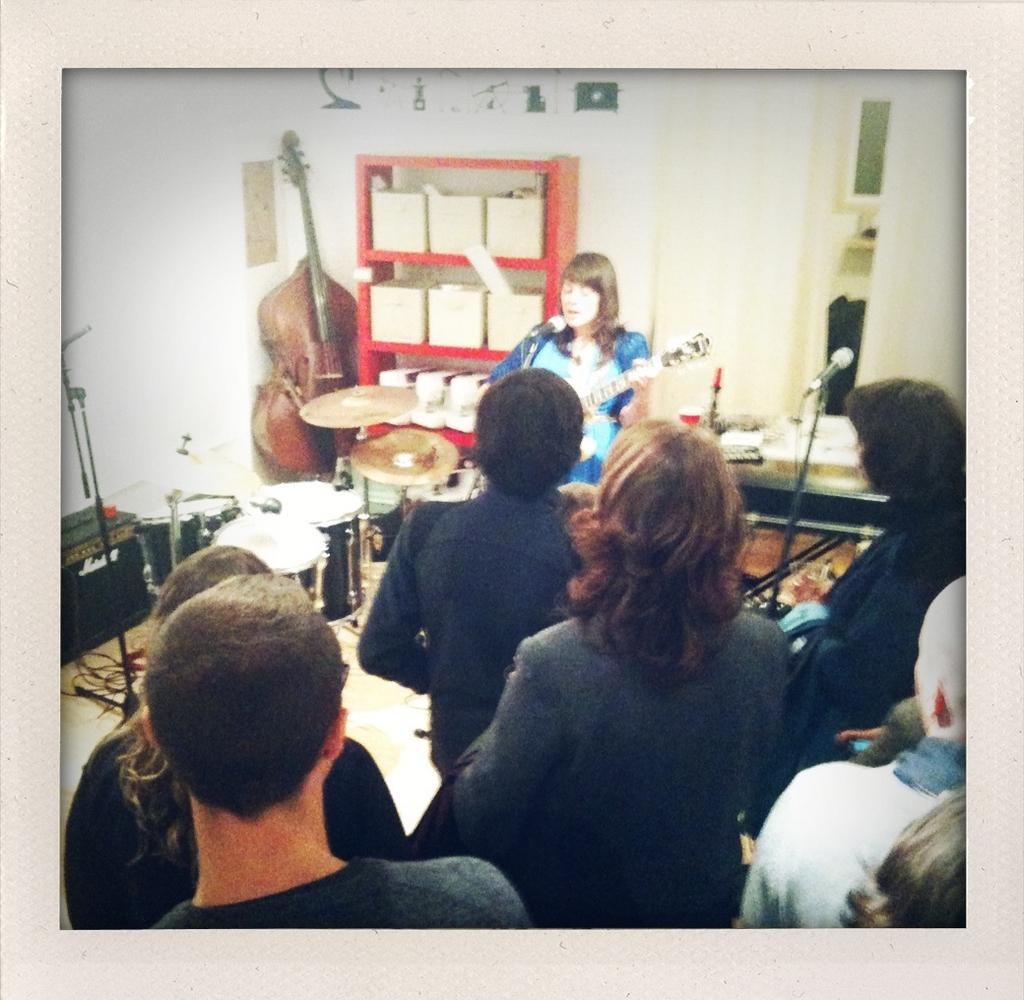How many people are in the image? There are people in the image, but the exact number is not specified. What is the woman doing in the image? The woman is playing a guitar in the image. What other items can be seen in the image besides the people? There are musical instruments, microphones, a rack, and other objects in the image. What is visible in the background of the image? There is a wall in the background of the image. What type of dress is the woman wearing while playing the guitar? The facts provided do not mention any dress or clothing worn by the woman, so we cannot determine the type of dress she is wearing. Is there any yarn visible in the image? There is no mention of yarn in the provided facts, so we cannot determine if it is present in the image. 